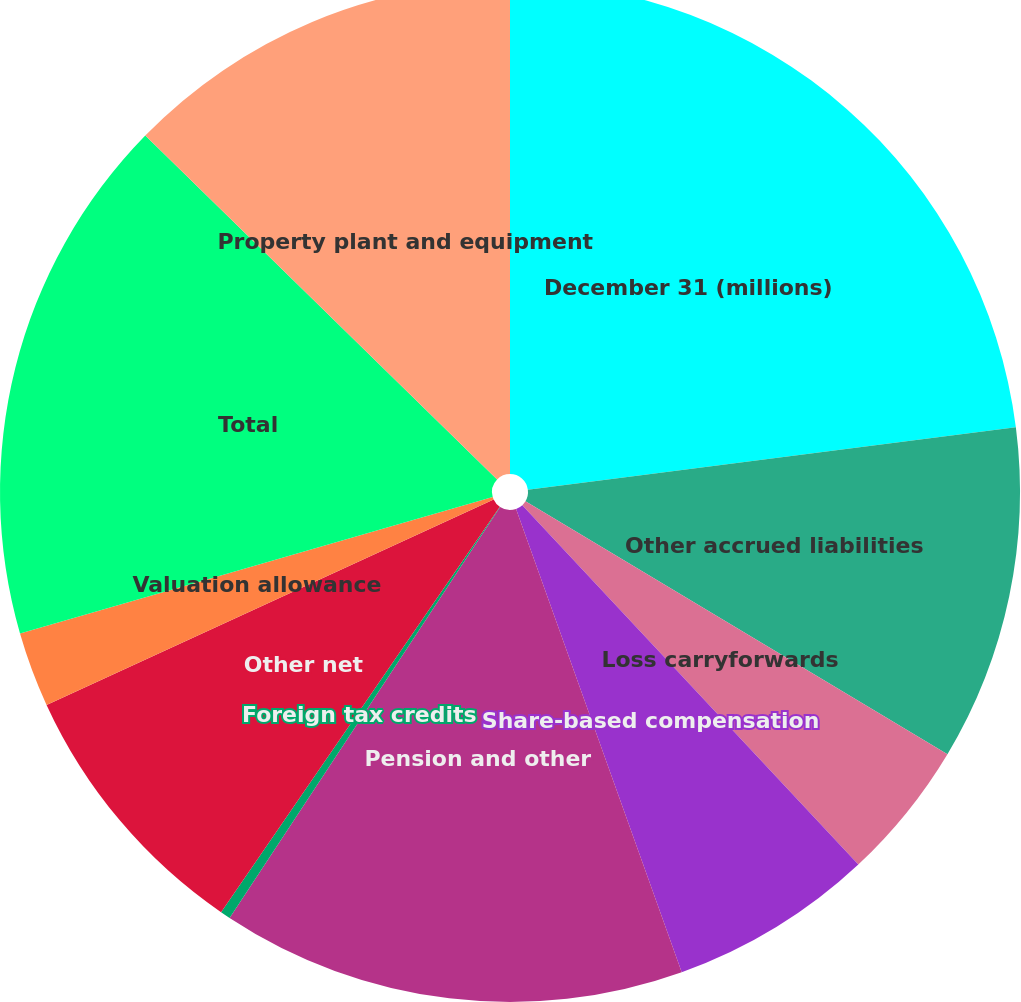<chart> <loc_0><loc_0><loc_500><loc_500><pie_chart><fcel>December 31 (millions)<fcel>Other accrued liabilities<fcel>Loss carryforwards<fcel>Share-based compensation<fcel>Pension and other<fcel>Foreign tax credits<fcel>Other net<fcel>Valuation allowance<fcel>Total<fcel>Property plant and equipment<nl><fcel>22.97%<fcel>10.62%<fcel>4.44%<fcel>6.5%<fcel>14.73%<fcel>0.32%<fcel>8.56%<fcel>2.38%<fcel>16.79%<fcel>12.68%<nl></chart> 